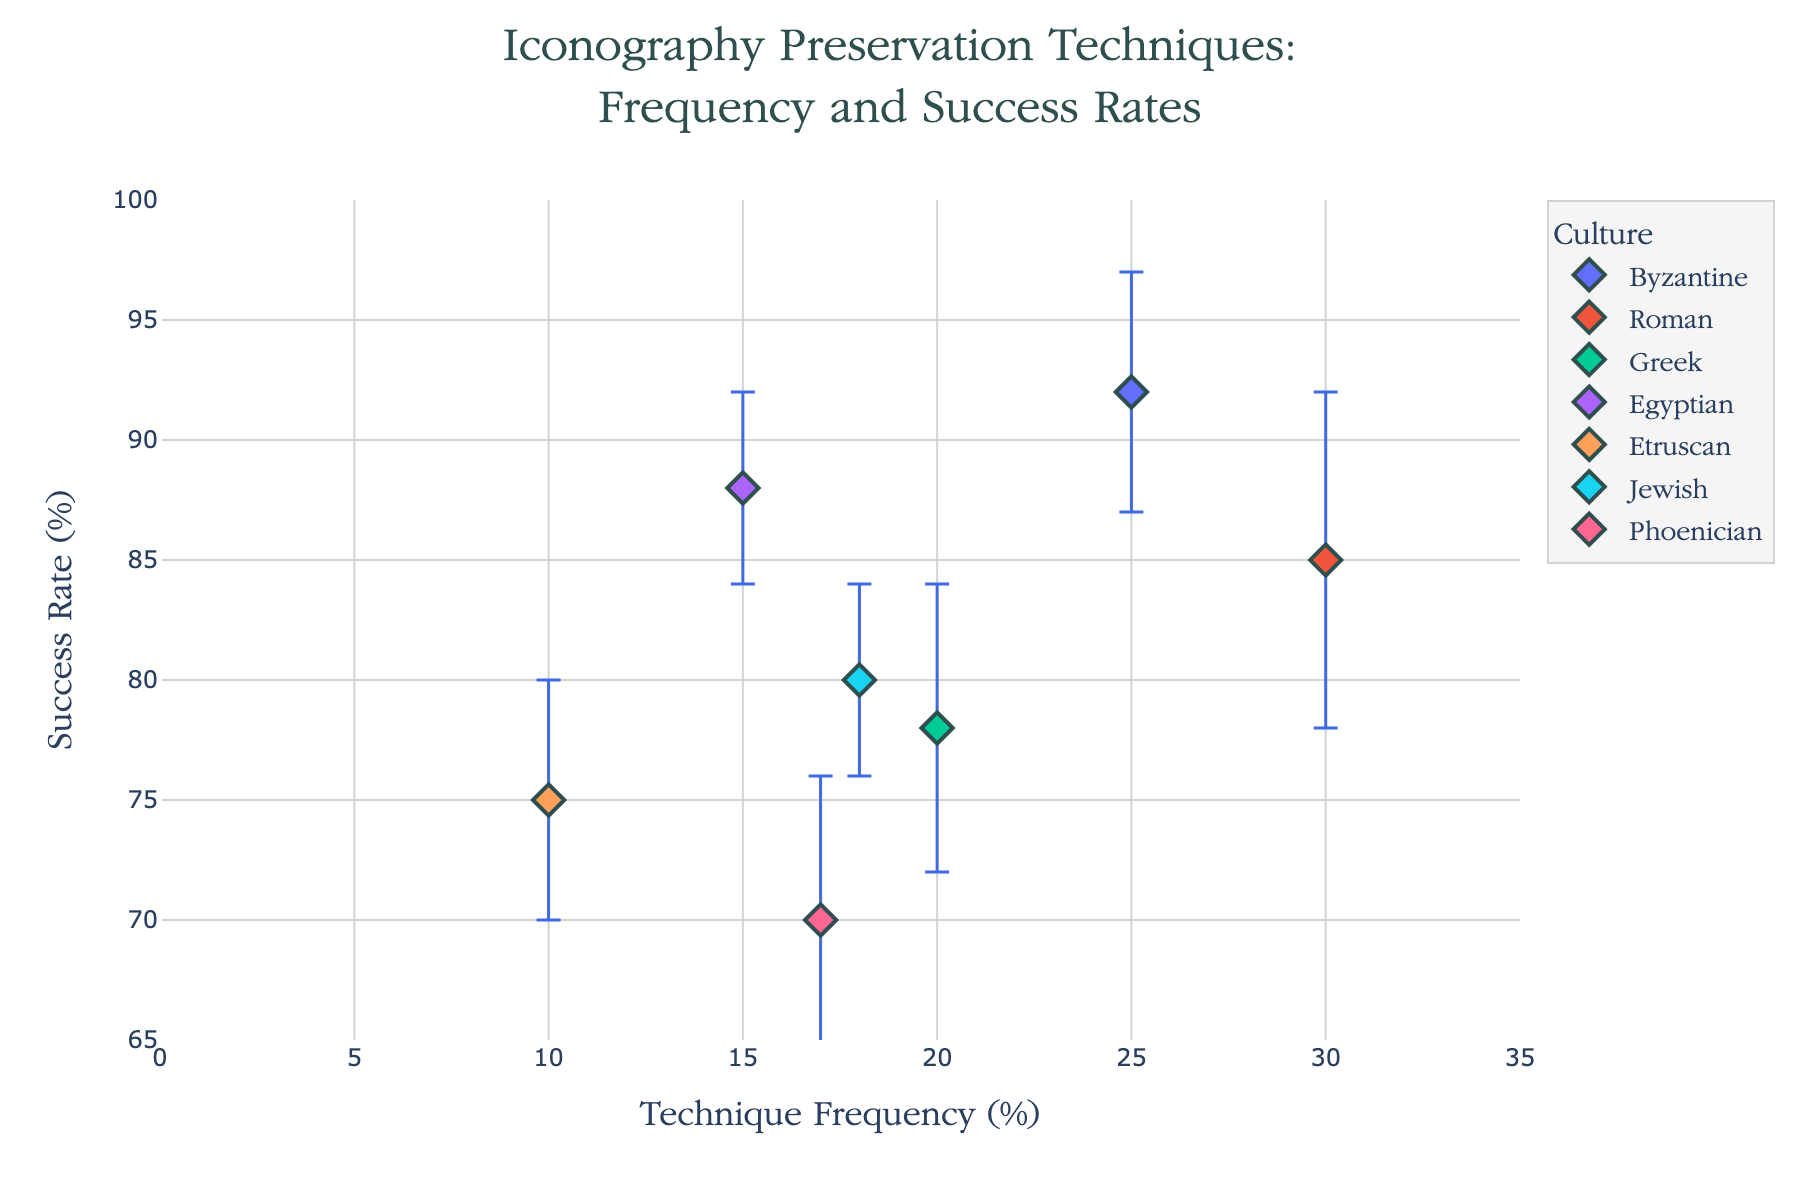Which technique has the highest success rate? To determine the technique with the highest success rate, inspect the y-axis values. "Encaustic Painting" for the Byzantine culture has the highest success rate of 92%.
Answer: Encaustic Painting What is the range of success rates for the techniques? To find the range, subtract the lowest success rate from the highest success rate. The highest is 92% (Byzantine, Encaustic Painting) and the lowest is 70% (Phoenician, Glass Tesserae Maintenance). The range is 92% - 70%.
Answer: 22% Which culture has the most frequently used technique? Check the x-axis values for the highest frequency. The Roman culture with "Mosaic Restoration" has the highest frequency of 30%.
Answer: Roman How does the success rate of Greek Fresco Replication compare to Jewish Coin Iconography Restoration? Compare their y-axis values. Greek Fresco Replication has a success rate of 78%, and Jewish Coin Iconography Restoration has a success rate of 80%. Therefore, the Jewish technique has a higher success rate by 2 percentage points.
Answer: Jewish is higher by 2% What is the average frequency percentage of all techniques? Add all frequency percentages and divide by the number of techniques. (25 + 30 + 20 + 15 + 10 + 18 + 17) / 7. The total is 135, and the average is 135 / 7.
Answer: 19.29% What technique has the smallest error bar? Error bars denote statistical uncertainty. The smallest error bar value is 4, and it is associated with both the Egyptian technique (Iconographic Stela Conservation) and Jewish technique (Coin Iconography Restoration).
Answer: Iconographic Stela Conservation; Coin Iconography Restoration Which culture's technique shows the largest uncertainty in success rate? Look for the largest error bar. The Roman culture "Mosaic Restoration" has the largest error bar of 7.
Answer: Roman Across all techniques, what is the median success rate? To find the median, list the success rates in ascending order: 70, 75, 78, 80, 85, 88, 92. The median is the middle value in this ordered list.
Answer: 80% Which culture has a technique with both moderate frequency and high success rate? Moderate frequency can be considered around 15-25%. High success rate is above 80%. The Byzantine culture with "Encaustic Painting" (25%, 92%) fits this description.
Answer: Byzantine 